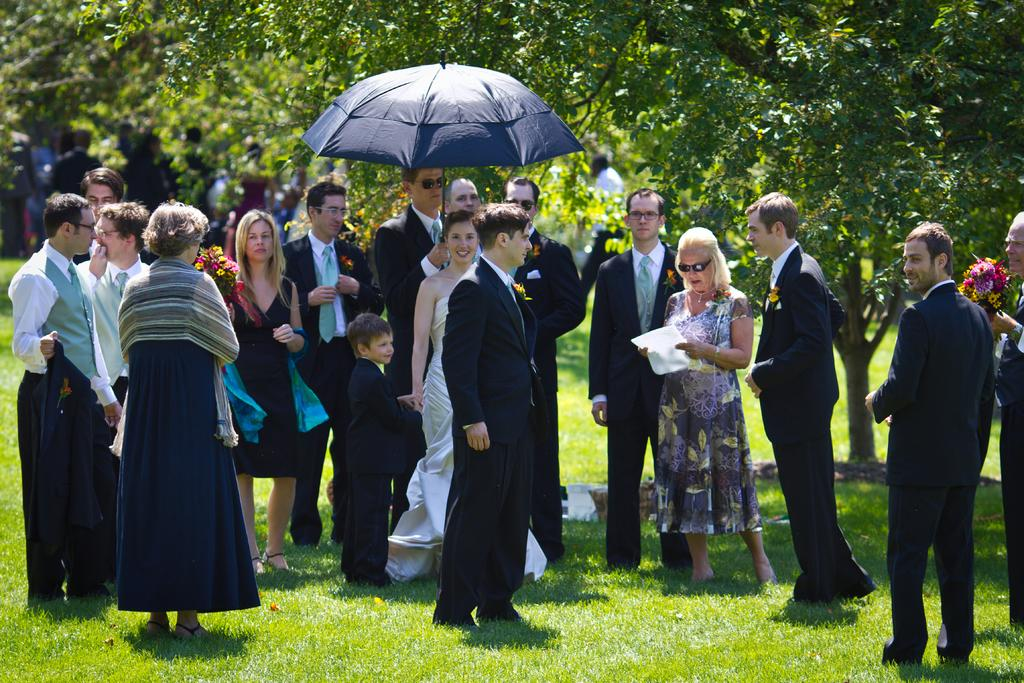What is happening in the foreground of the image? There are persons standing in the foreground of the image. What is the surface on which the persons are standing? The persons are standing on the grass. What is the predominant color of the dresses worn by the persons? Most of the persons are wearing black dresses. Can you describe the background of the image? There are persons and trees visible in the background of the image, and there is also grass. What type of vein can be seen running through the jar in the image? There is no jar or vein present in the image. How does the rainstorm affect the persons standing in the image? There is no rainstorm present in the image; the persons are standing on a grassy surface with no visible precipitation. 